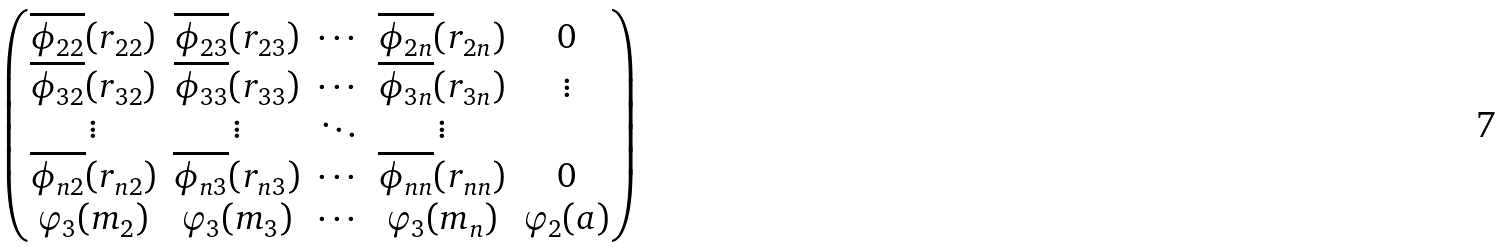<formula> <loc_0><loc_0><loc_500><loc_500>\begin{pmatrix} \overline { \phi _ { 2 2 } } ( r _ { 2 2 } ) & \overline { \phi _ { 2 3 } } ( r _ { 2 3 } ) & \cdots & \overline { \phi _ { 2 n } } ( r _ { 2 n } ) & 0 \\ \overline { \phi _ { 3 2 } } ( r _ { 3 2 } ) & \overline { \phi _ { 3 3 } } ( r _ { 3 3 } ) & \cdots & \overline { \phi _ { 3 n } } ( r _ { 3 n } ) & \vdots \\ \vdots & \vdots & \ddots & \vdots & \\ \overline { \phi _ { n 2 } } ( r _ { n 2 } ) & \overline { \phi _ { n 3 } } ( r _ { n 3 } ) & \cdots & \overline { \phi _ { n n } } ( r _ { n n } ) & 0 \\ \varphi _ { 3 } ( m _ { 2 } ) & \varphi _ { 3 } ( m _ { 3 } ) & \cdots & \varphi _ { 3 } ( m _ { n } ) & \varphi _ { 2 } ( a ) \end{pmatrix}</formula> 